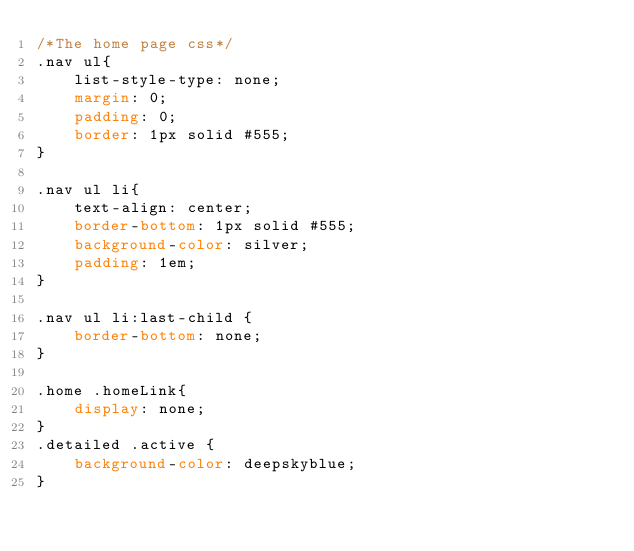<code> <loc_0><loc_0><loc_500><loc_500><_CSS_>/*The home page css*/
.nav ul{
    list-style-type: none;
    margin: 0;
    padding: 0;
    border: 1px solid #555;
}

.nav ul li{
    text-align: center;
    border-bottom: 1px solid #555;
    background-color: silver;
    padding: 1em;
}

.nav ul li:last-child {
    border-bottom: none;
}

.home .homeLink{
    display: none;
}
.detailed .active {
    background-color: deepskyblue;
}

</code> 